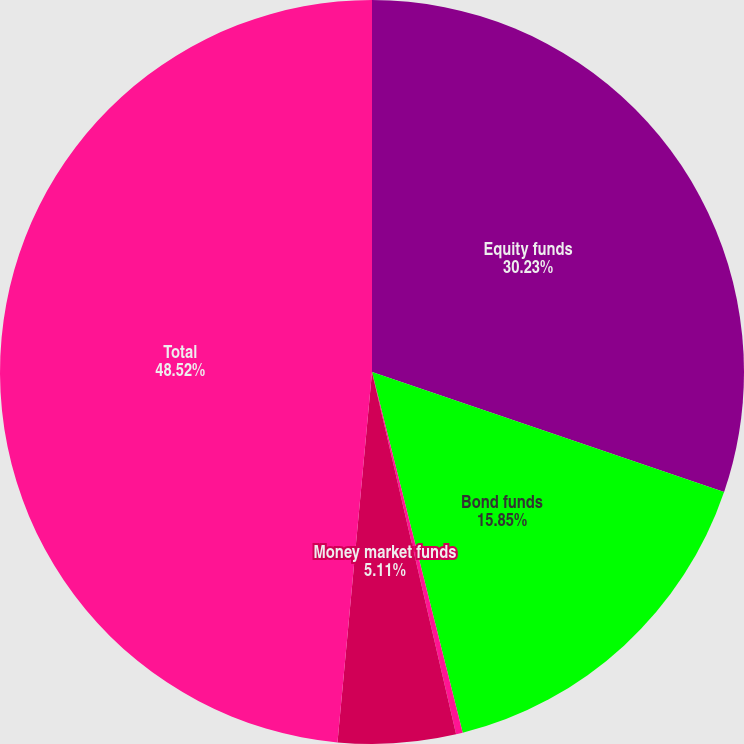Convert chart. <chart><loc_0><loc_0><loc_500><loc_500><pie_chart><fcel>Equity funds<fcel>Bond funds<fcel>Balanced funds<fcel>Money market funds<fcel>Total<nl><fcel>30.23%<fcel>15.85%<fcel>0.29%<fcel>5.11%<fcel>48.52%<nl></chart> 